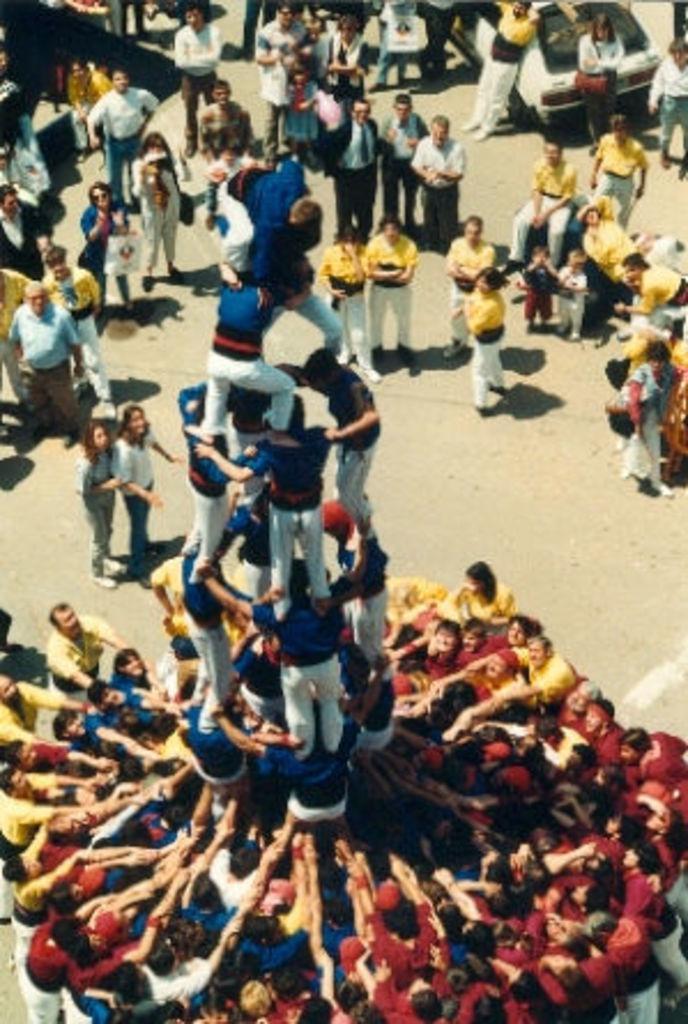Please provide a concise description of this image. In this image I can see the group of people with different color dresses. To the side of these people I can see the vehicle. These people are on the road. 